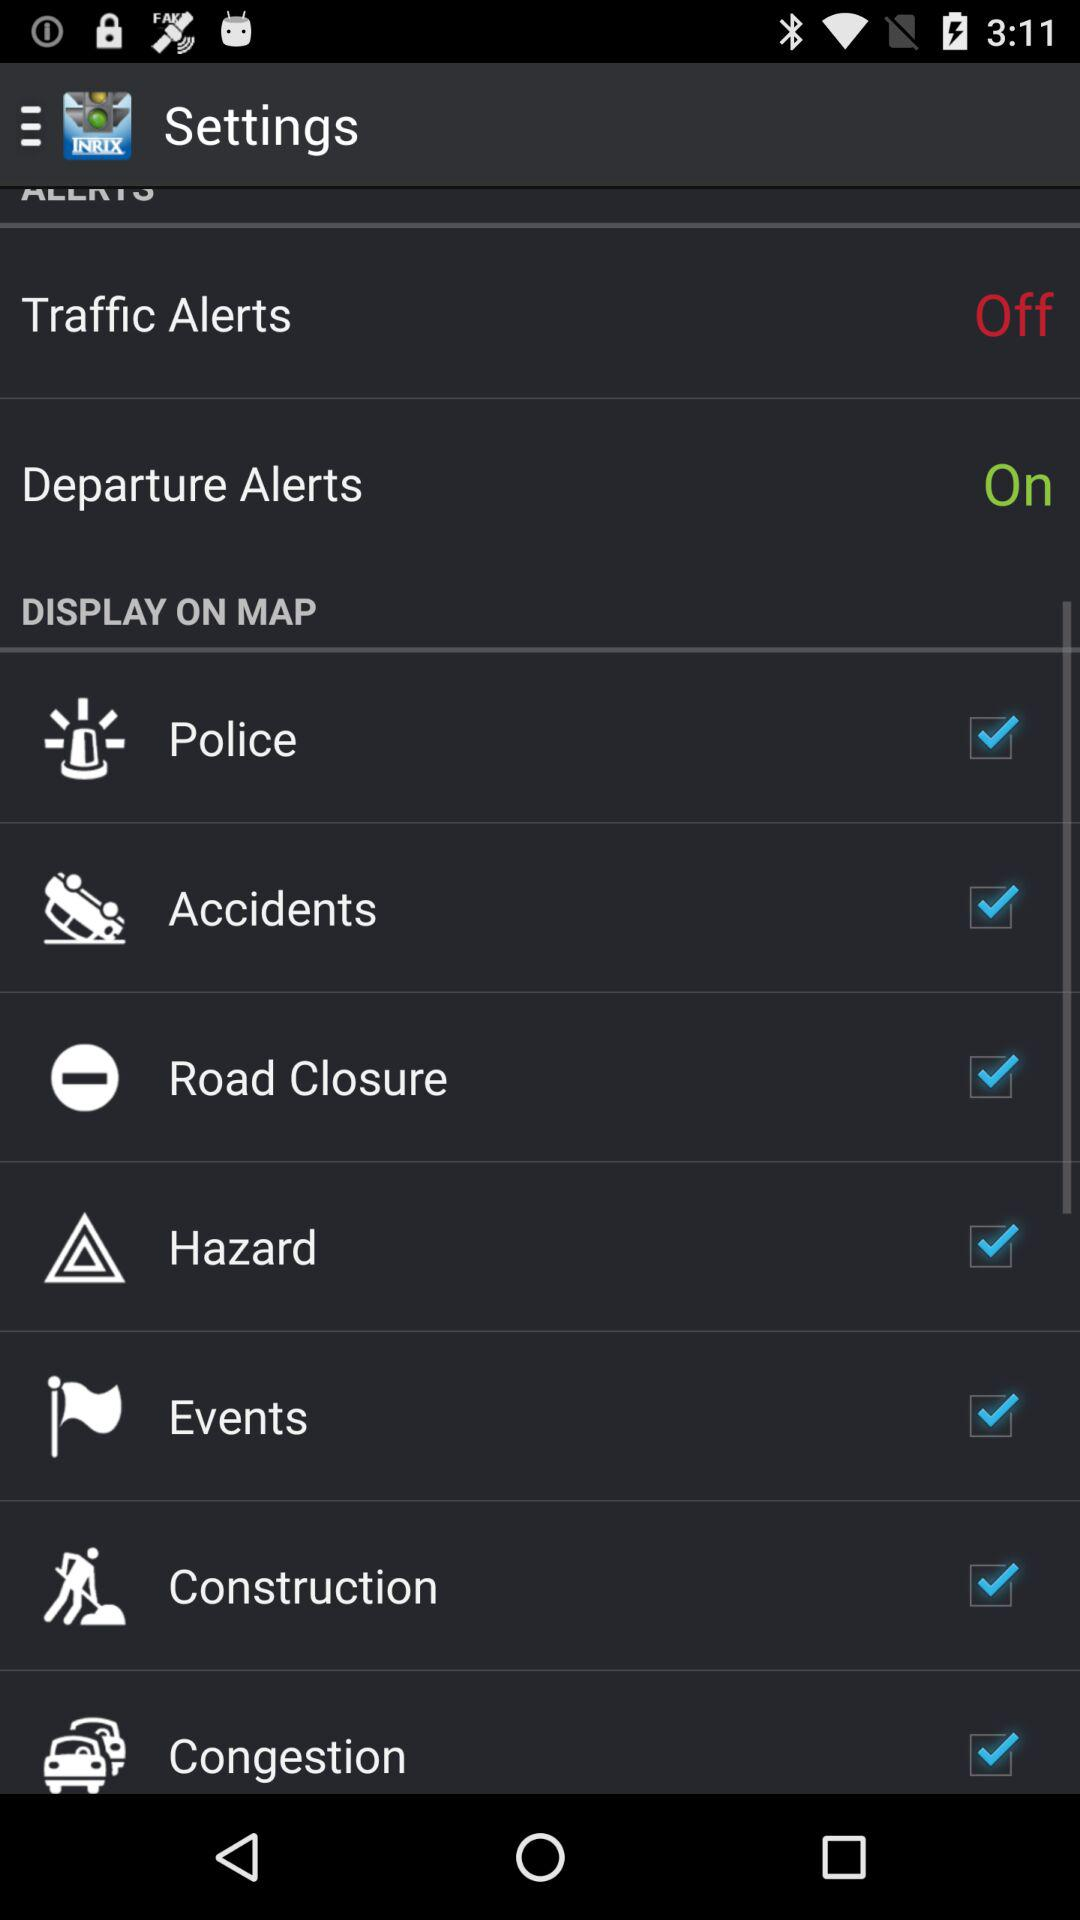What is the status of "Departure Alerts"? The status is "on". 